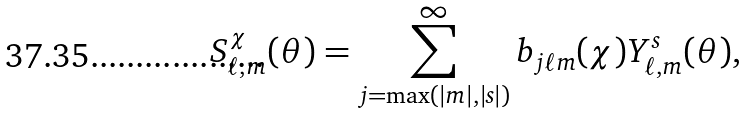<formula> <loc_0><loc_0><loc_500><loc_500>S ^ { \chi } _ { \ell , m } ( \theta ) = \sum _ { j = \max ( | m | , | s | ) } ^ { \infty } b _ { j \ell m } ( \chi ) Y ^ { s } _ { \ell , m } ( \theta ) ,</formula> 